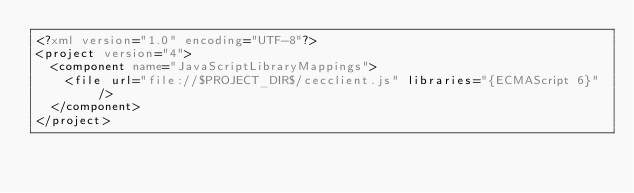Convert code to text. <code><loc_0><loc_0><loc_500><loc_500><_XML_><?xml version="1.0" encoding="UTF-8"?>
<project version="4">
  <component name="JavaScriptLibraryMappings">
    <file url="file://$PROJECT_DIR$/cecclient.js" libraries="{ECMAScript 6}" />
  </component>
</project></code> 